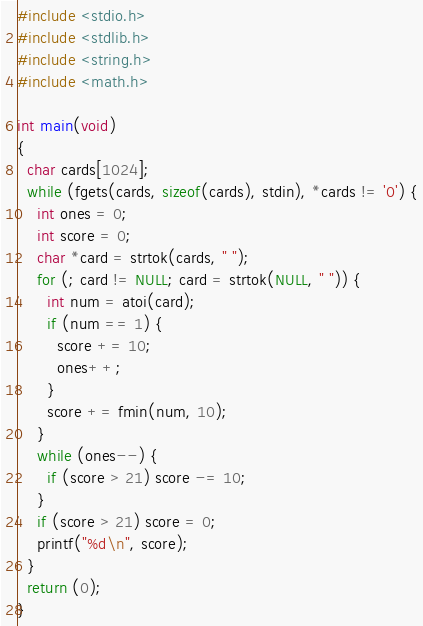<code> <loc_0><loc_0><loc_500><loc_500><_C_>#include <stdio.h>
#include <stdlib.h>
#include <string.h>
#include <math.h>

int main(void)
{
  char cards[1024];
  while (fgets(cards, sizeof(cards), stdin), *cards != '0') {
    int ones = 0;
    int score = 0;
    char *card = strtok(cards, " ");
    for (; card != NULL; card = strtok(NULL, " ")) {
      int num = atoi(card);
      if (num == 1) {
        score += 10;
        ones++;
      }
      score += fmin(num, 10);
    }
    while (ones--) {
      if (score > 21) score -= 10;
    }
    if (score > 21) score = 0;
    printf("%d\n", score);
  } 
  return (0);
}</code> 